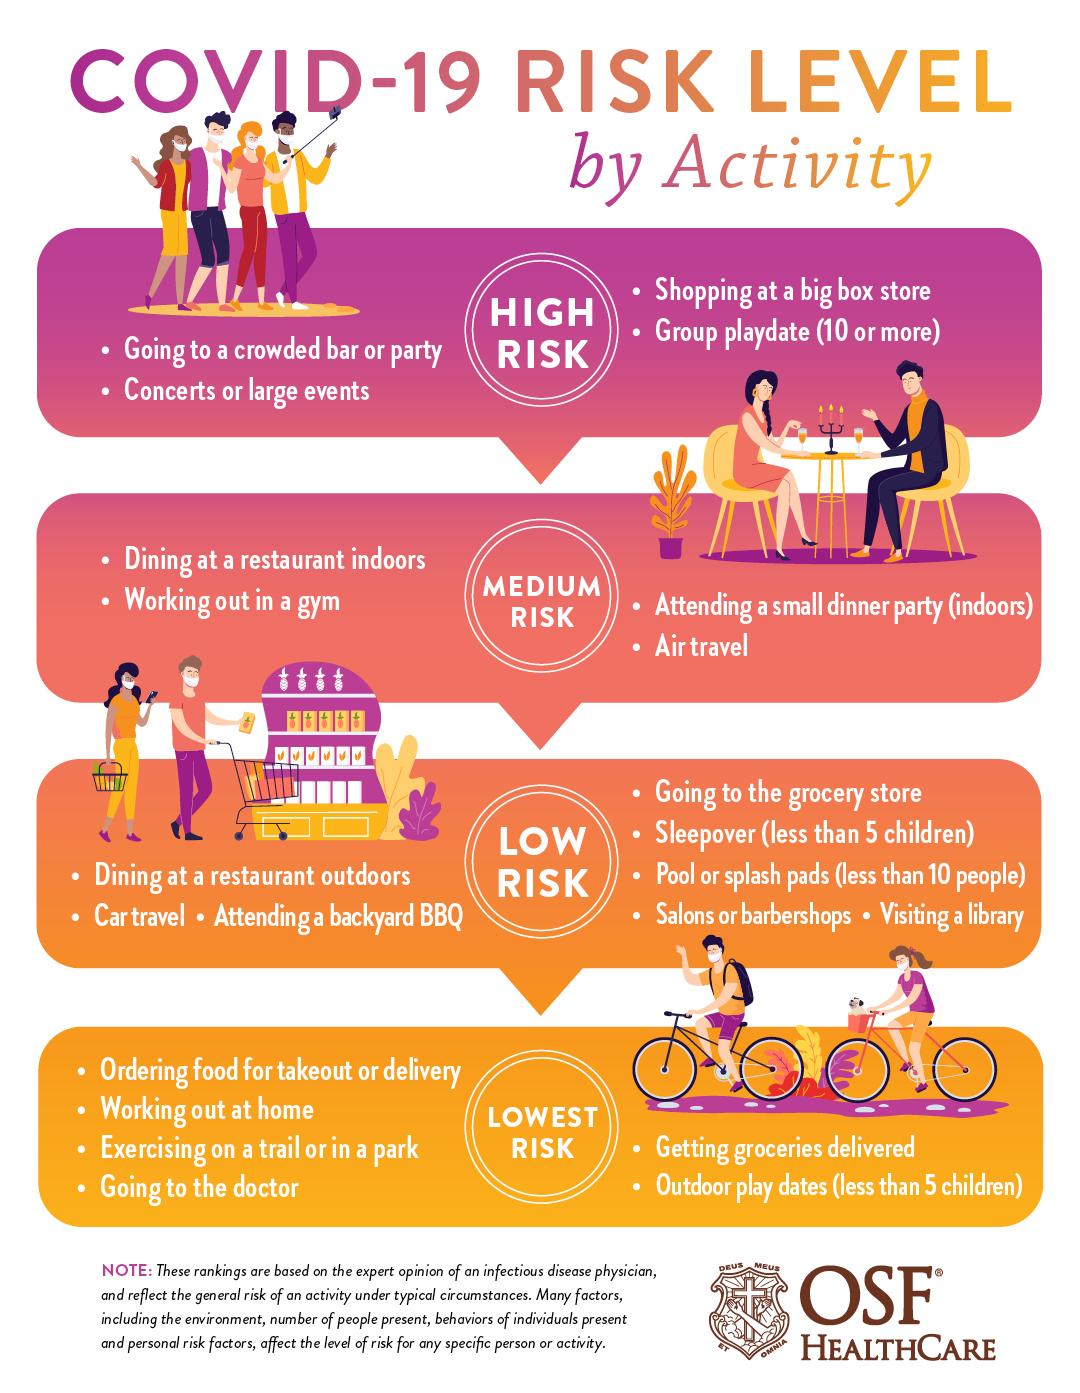Outline some significant characteristics in this image. Working out at home is categorized as having the lowest risk in relation to COVID-19. COVID-19 poses a low risk when dining at a restaurant outdoors. The concerts or large events category is considered high risk for COVID-19. The COVID-19 virus poses a medium risk to individuals who have been exposed to air travel. 